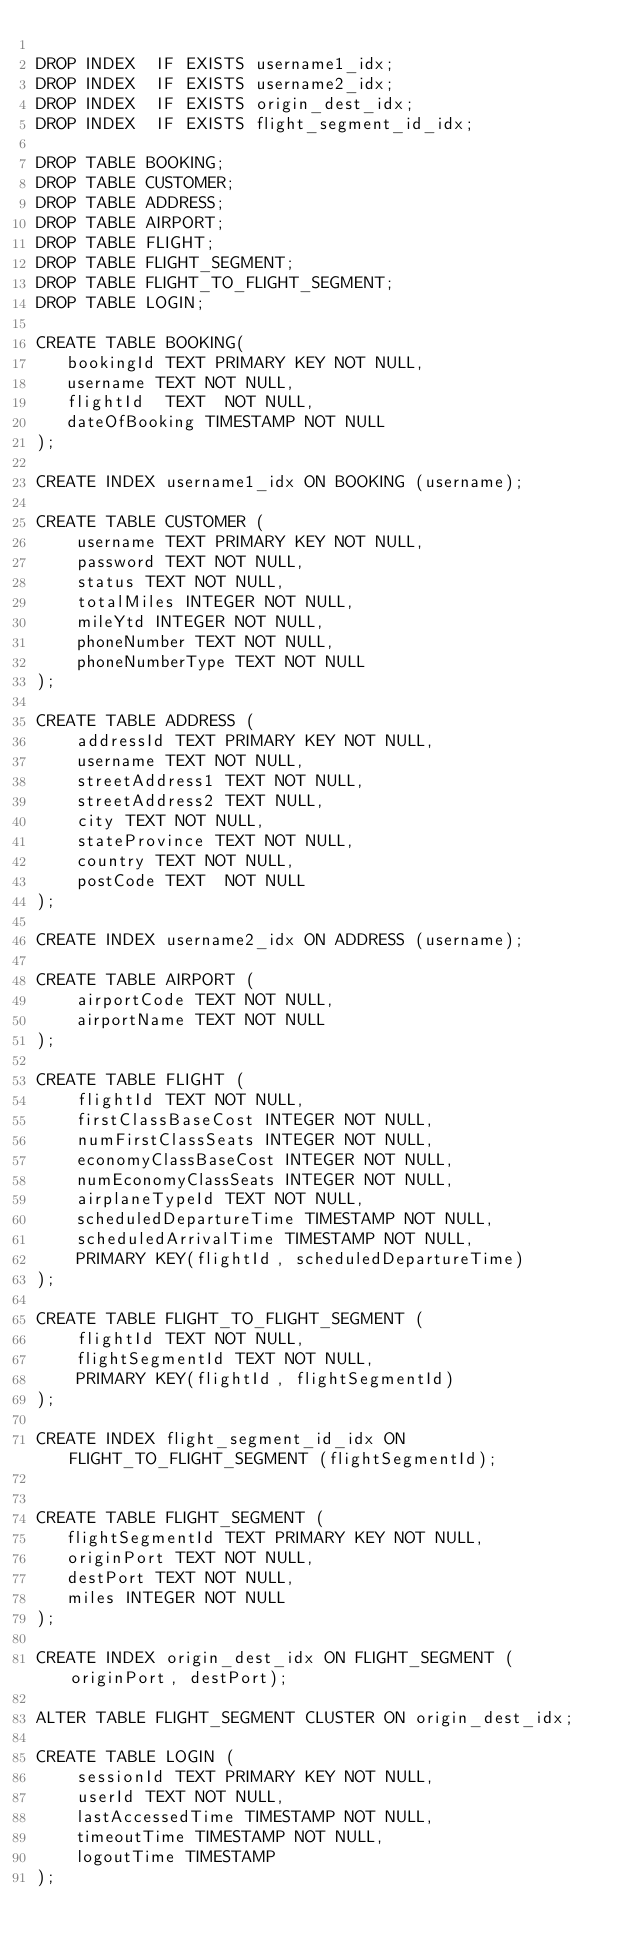<code> <loc_0><loc_0><loc_500><loc_500><_SQL_>
DROP INDEX  IF EXISTS username1_idx;
DROP INDEX  IF EXISTS username2_idx;
DROP INDEX  IF EXISTS origin_dest_idx;
DROP INDEX  IF EXISTS flight_segment_id_idx;

DROP TABLE BOOKING;
DROP TABLE CUSTOMER;
DROP TABLE ADDRESS;
DROP TABLE AIRPORT;
DROP TABLE FLIGHT;
DROP TABLE FLIGHT_SEGMENT;
DROP TABLE FLIGHT_TO_FLIGHT_SEGMENT;
DROP TABLE LOGIN;

CREATE TABLE BOOKING(
   bookingId TEXT PRIMARY KEY NOT NULL,
   username TEXT NOT NULL,
   flightId  TEXT  NOT NULL,
   dateOfBooking TIMESTAMP NOT NULL
);

CREATE INDEX username1_idx ON BOOKING (username);

CREATE TABLE CUSTOMER (
    username TEXT PRIMARY KEY NOT NULL,
    password TEXT NOT NULL,
    status TEXT NOT NULL,
    totalMiles INTEGER NOT NULL,
    mileYtd INTEGER NOT NULL,
    phoneNumber TEXT NOT NULL,
    phoneNumberType TEXT NOT NULL
);

CREATE TABLE ADDRESS (
    addressId TEXT PRIMARY KEY NOT NULL,
    username TEXT NOT NULL,
    streetAddress1 TEXT NOT NULL,
    streetAddress2 TEXT NULL,
    city TEXT NOT NULL,
    stateProvince TEXT NOT NULL,
    country TEXT NOT NULL,
    postCode TEXT  NOT NULL
);

CREATE INDEX username2_idx ON ADDRESS (username);

CREATE TABLE AIRPORT (
    airportCode TEXT NOT NULL,
    airportName TEXT NOT NULL
);

CREATE TABLE FLIGHT (
    flightId TEXT NOT NULL,
    firstClassBaseCost INTEGER NOT NULL,
    numFirstClassSeats INTEGER NOT NULL,
    economyClassBaseCost INTEGER NOT NULL,
    numEconomyClassSeats INTEGER NOT NULL,
    airplaneTypeId TEXT NOT NULL,
    scheduledDepartureTime TIMESTAMP NOT NULL,
    scheduledArrivalTime TIMESTAMP NOT NULL,
    PRIMARY KEY(flightId, scheduledDepartureTime)
);

CREATE TABLE FLIGHT_TO_FLIGHT_SEGMENT (
    flightId TEXT NOT NULL,
    flightSegmentId TEXT NOT NULL,
    PRIMARY KEY(flightId, flightSegmentId)
);

CREATE INDEX flight_segment_id_idx ON FLIGHT_TO_FLIGHT_SEGMENT (flightSegmentId);


CREATE TABLE FLIGHT_SEGMENT (
   flightSegmentId TEXT PRIMARY KEY NOT NULL,
   originPort TEXT NOT NULL,
   destPort TEXT NOT NULL,
   miles INTEGER NOT NULL
);

CREATE INDEX origin_dest_idx ON FLIGHT_SEGMENT (originPort, destPort);

ALTER TABLE FLIGHT_SEGMENT CLUSTER ON origin_dest_idx;

CREATE TABLE LOGIN (
    sessionId TEXT PRIMARY KEY NOT NULL,
    userId TEXT NOT NULL,
    lastAccessedTime TIMESTAMP NOT NULL,
    timeoutTime TIMESTAMP NOT NULL,
    logoutTime TIMESTAMP
);

</code> 